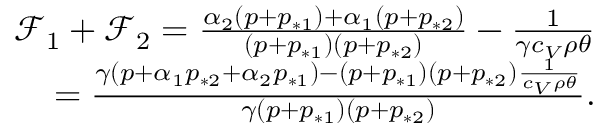Convert formula to latex. <formula><loc_0><loc_0><loc_500><loc_500>\begin{array} { r } { \mathcal { F } _ { 1 } + \mathcal { F } _ { 2 } = \frac { \alpha _ { 2 } ( p + p _ { * 1 } ) + \alpha _ { 1 } ( p + p _ { * 2 } ) } { ( p + p _ { * 1 } ) ( p + p _ { * 2 } ) } - \frac { 1 } { \gamma c _ { V } \rho \theta } } \\ { = \frac { \gamma ( p + \alpha _ { 1 } p _ { * 2 } + \alpha _ { 2 } p _ { * 1 } ) - ( p + p _ { * 1 } ) ( p + p _ { * 2 } ) \frac { 1 } { c _ { V } \rho \theta } } { \gamma ( p + p _ { * 1 } ) ( p + p _ { * 2 } ) } . } \end{array}</formula> 